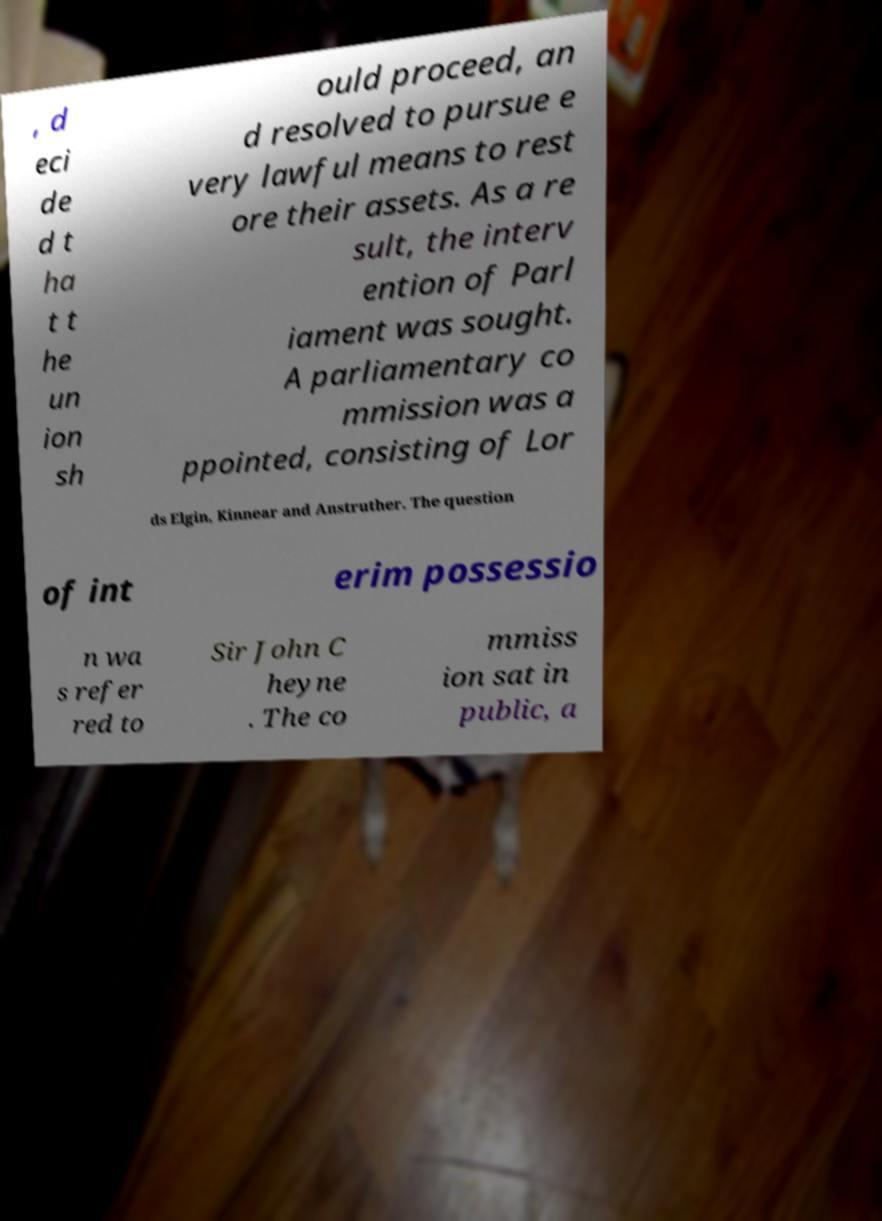Could you assist in decoding the text presented in this image and type it out clearly? , d eci de d t ha t t he un ion sh ould proceed, an d resolved to pursue e very lawful means to rest ore their assets. As a re sult, the interv ention of Parl iament was sought. A parliamentary co mmission was a ppointed, consisting of Lor ds Elgin, Kinnear and Anstruther. The question of int erim possessio n wa s refer red to Sir John C heyne . The co mmiss ion sat in public, a 